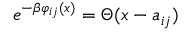<formula> <loc_0><loc_0><loc_500><loc_500>e ^ { - \beta \varphi _ { i j } ( x ) } = \Theta ( x - a _ { i j } )</formula> 